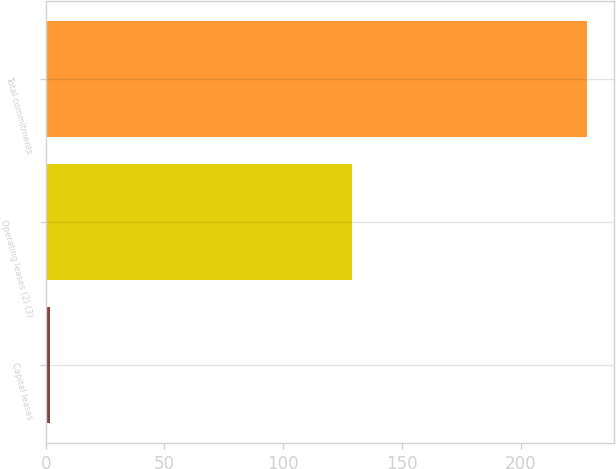<chart> <loc_0><loc_0><loc_500><loc_500><bar_chart><fcel>Capital leases<fcel>Operating leases (2) (3)<fcel>Total commitments<nl><fcel>2<fcel>129<fcel>228<nl></chart> 